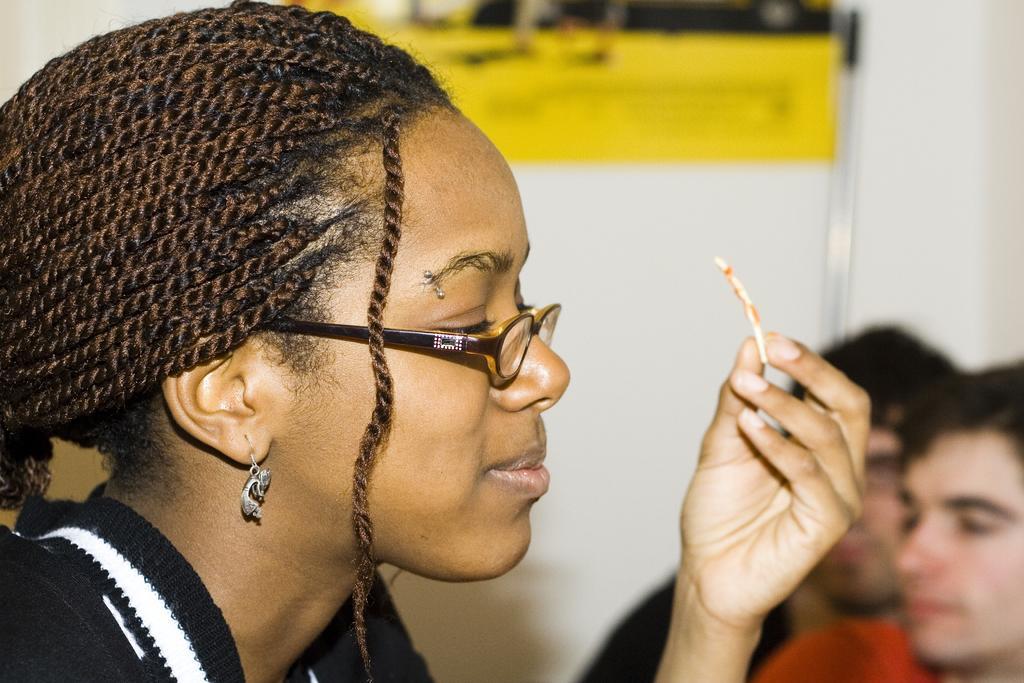Please provide a concise description of this image. There is one girl holding an object on the left side of this image. We can see some persons in the bottom right corner of this image and there is a wall in the background. We can see a poster attached to a wall. 